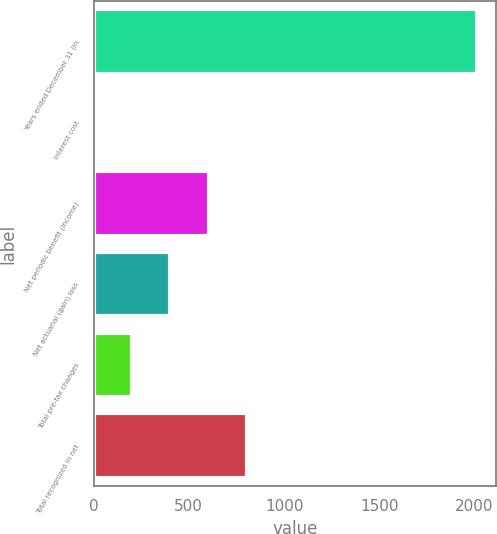Convert chart to OTSL. <chart><loc_0><loc_0><loc_500><loc_500><bar_chart><fcel>Years ended December 31 (in<fcel>Interest cost<fcel>Net periodic benefit (income)<fcel>Net actuarial (gain) loss<fcel>Total pre-tax changes<fcel>Total recognized in net<nl><fcel>2011<fcel>0.6<fcel>603.72<fcel>402.68<fcel>201.64<fcel>804.76<nl></chart> 